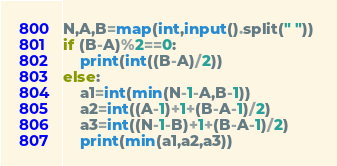Convert code to text. <code><loc_0><loc_0><loc_500><loc_500><_Python_>N,A,B=map(int,input().split(" ")) 
if (B-A)%2==0:
    print(int((B-A)/2))
else:
    a1=int(min(N-1-A,B-1))
    a2=int((A-1)+1+(B-A-1)/2)
    a3=int((N-1-B)+1+(B-A-1)/2)
    print(min(a1,a2,a3))</code> 